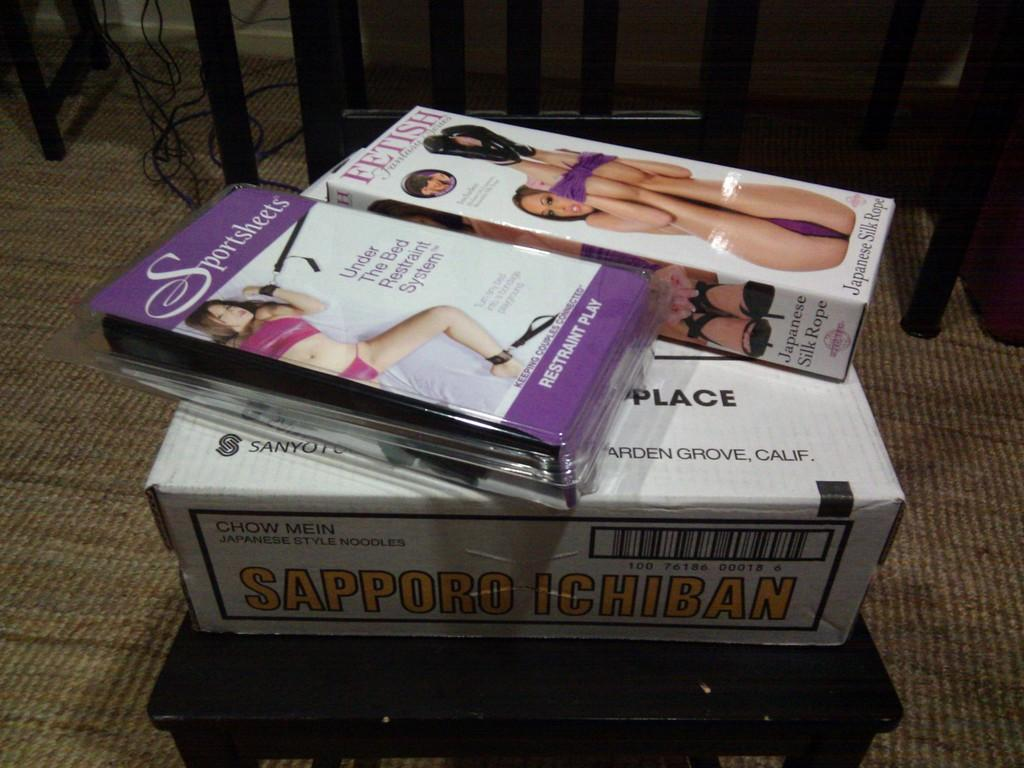How many boxes are on the chair in the image? There are three boxes on a chair in the image. What else can be seen in the image besides the boxes? There are wires visible in the image. Are there any objects on the floor in the image? Yes, there are objects on the floor in the image. Who is the expert in the image? There is no expert present in the image. How many cups are visible in the image? There are no cups visible in the image. 